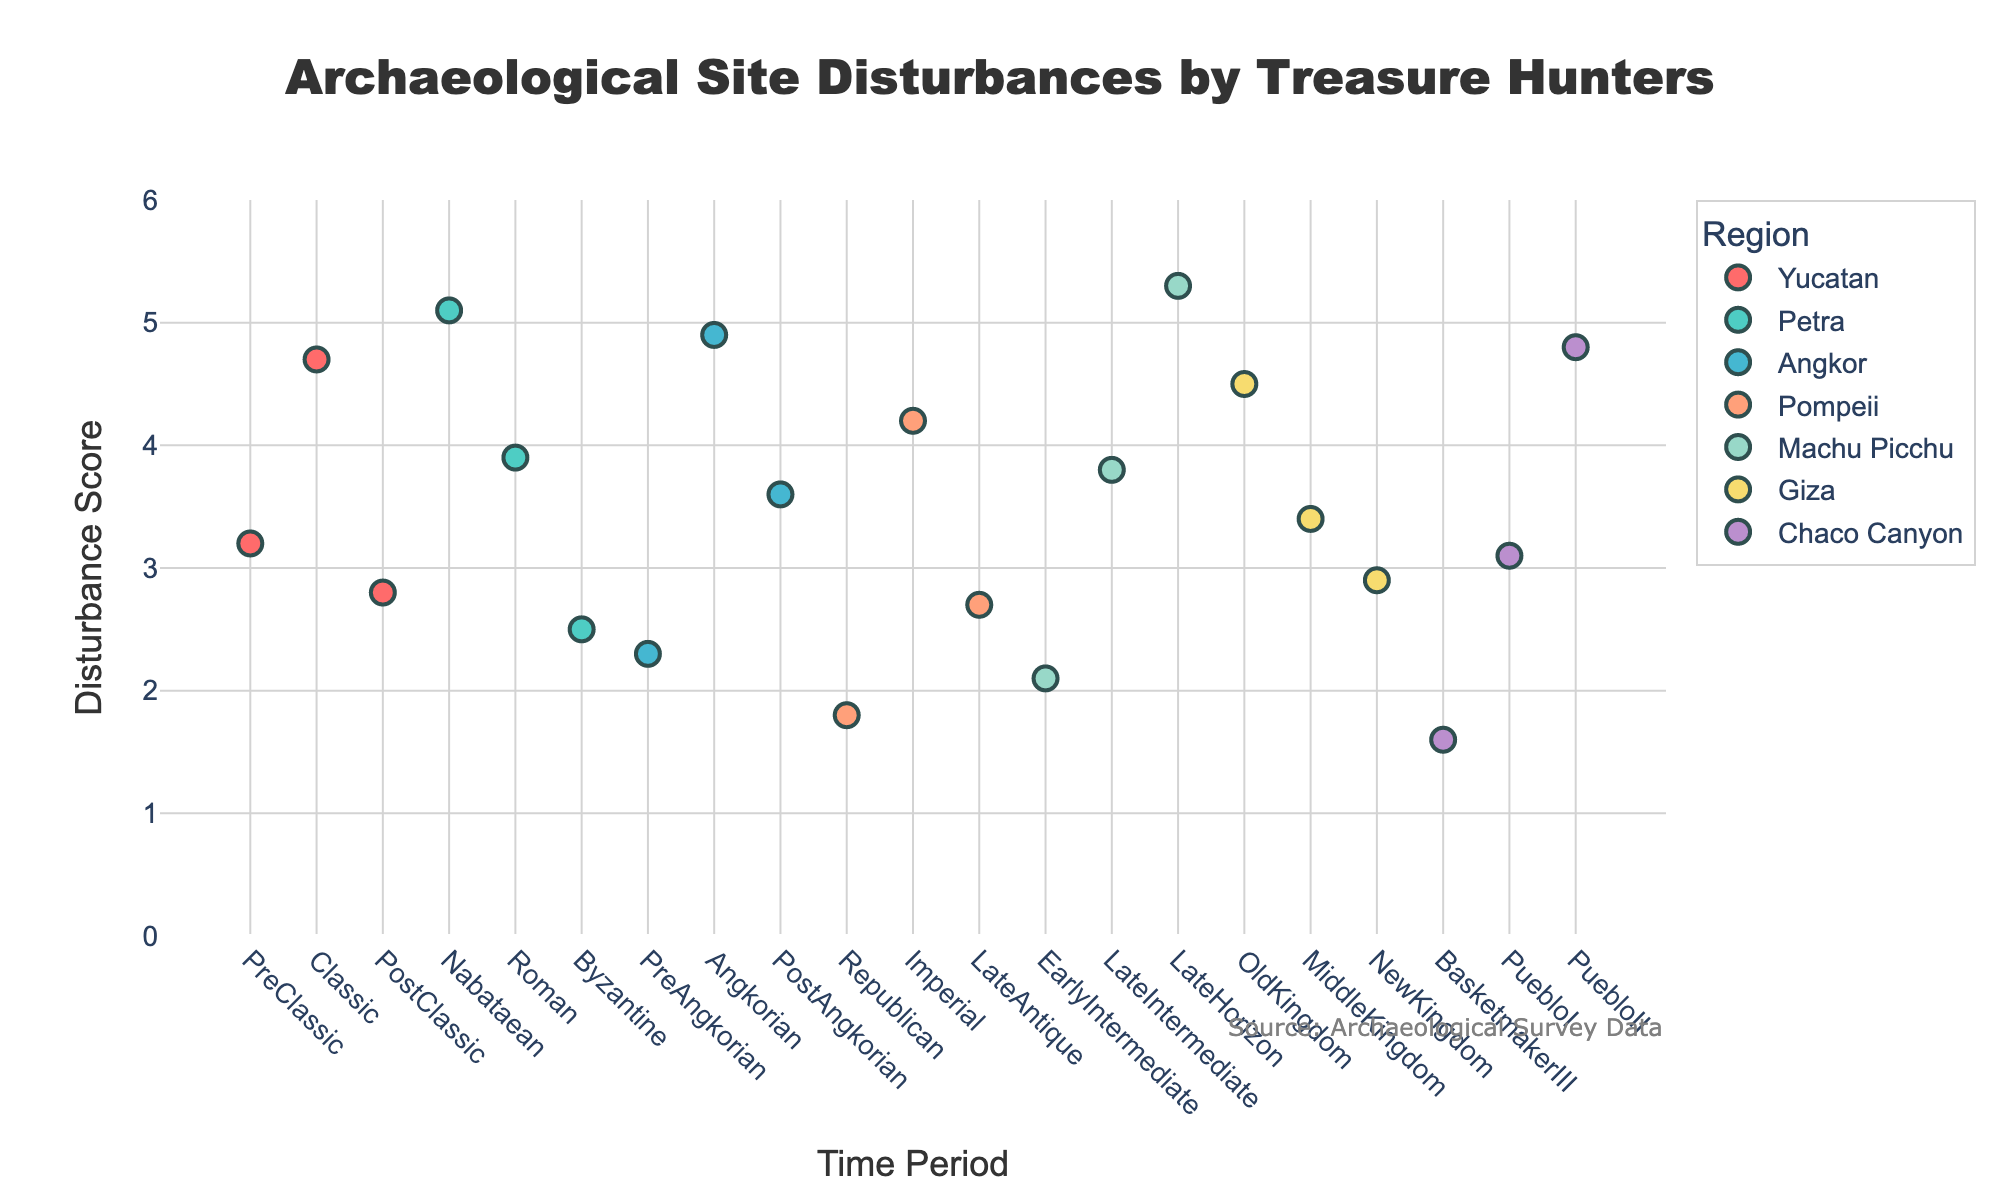What's the title of the figure? The title of the figure is prominently displayed at the top.
Answer: Archaeological Site Disturbances by Treasure Hunters What is the disturbance score range used in the y-axis? The y-axis range is labeled from 0 to 6.
Answer: 0 to 6 Which region has the highest disturbance score? The points in the figure show that Machu Picchu in the Late Horizon time period has the highest disturbance score of 5.3.
Answer: Machu Picchu How does the disturbance score for the Classic Period in Yucatan compare with the PreClassic Period in Yucatan? The Classic Period in Yucatan has a disturbance score of 4.7, which is higher than the PreClassic Period which has a score of 3.2.
Answer: Classic is higher What is the average disturbance score for Giza across all time periods? The disturbance scores for Giza are 4.5, 3.4, and 2.9. The average is (4.5 + 3.4 + 2.9) / 3 = 3.6.
Answer: 3.6 Which region has the lowest disturbance score and in which time period? Chaco Canyon during the Basketmaker III Period has the lowest disturbance score of 1.6.
Answer: Chaco Canyon, Basketmaker III Does Petra or Angkor have a higher disturbance score during their peak periods? Petra during the Nabataean Period has a disturbance score of 5.1, which is higher than Angkor during the Angkorian Period which has a score of 4.9.
Answer: Petra What is the change in disturbance score between the PreAngkorian and Angkorian periods for Angkor? The disturbance score changes from 2.3 during the PreAngkorian period to 4.9 during the Angkorian period, a difference of 4.9 - 2.3 = 2.6.
Answer: 2.6 Which region shows the most variability in disturbance scores across time periods? Comparing the spread of disturbance scores visually, Pompeii shows a range from 1.8 to 4.2 which is the largest spread.
Answer: Pompeii 